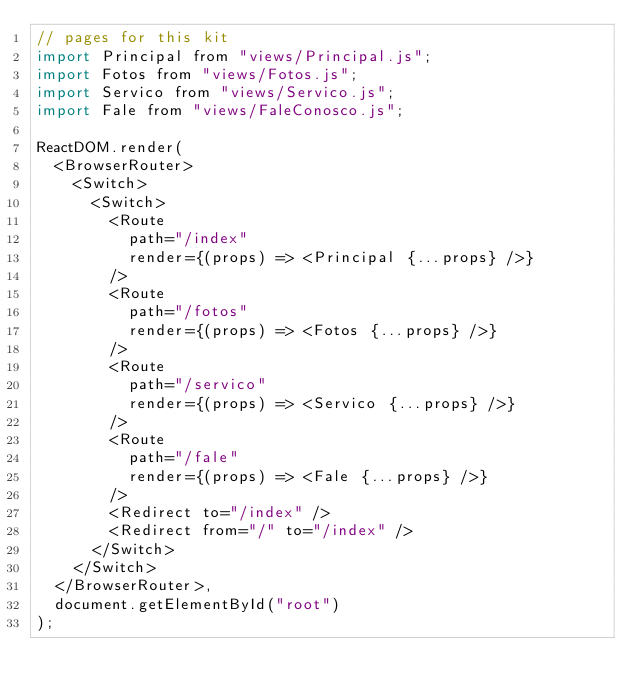Convert code to text. <code><loc_0><loc_0><loc_500><loc_500><_JavaScript_>// pages for this kit
import Principal from "views/Principal.js";
import Fotos from "views/Fotos.js";
import Servico from "views/Servico.js";
import Fale from "views/FaleConosco.js";

ReactDOM.render(
  <BrowserRouter>
    <Switch>
      <Switch>
        <Route
          path="/index"
          render={(props) => <Principal {...props} />}
        />
		<Route
          path="/fotos"
          render={(props) => <Fotos {...props} />}
        />
		<Route
          path="/servico"
          render={(props) => <Servico {...props} />}
        />
		<Route
          path="/fale"
          render={(props) => <Fale {...props} />}
        />
        <Redirect to="/index" />
        <Redirect from="/" to="/index" />
      </Switch>
    </Switch>
  </BrowserRouter>,
  document.getElementById("root")
);
</code> 